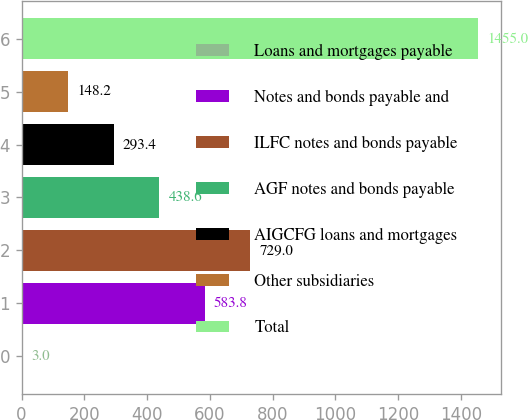<chart> <loc_0><loc_0><loc_500><loc_500><bar_chart><fcel>Loans and mortgages payable<fcel>Notes and bonds payable and<fcel>ILFC notes and bonds payable<fcel>AGF notes and bonds payable<fcel>AIGCFG loans and mortgages<fcel>Other subsidiaries<fcel>Total<nl><fcel>3<fcel>583.8<fcel>729<fcel>438.6<fcel>293.4<fcel>148.2<fcel>1455<nl></chart> 